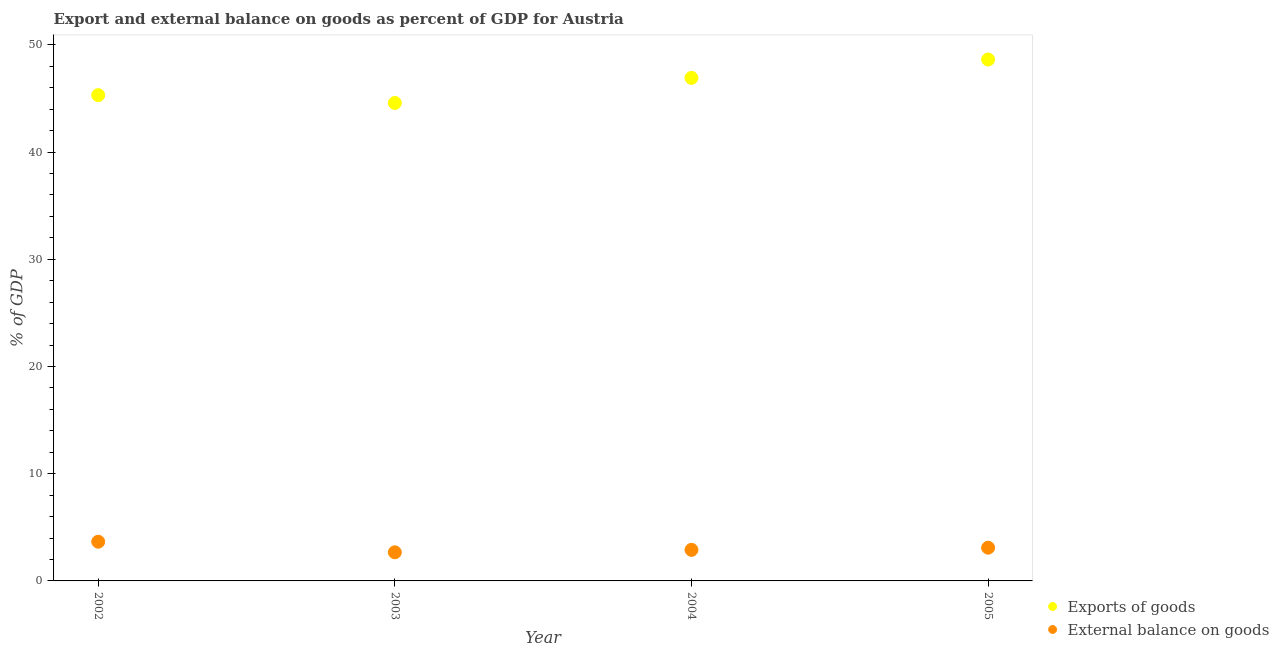Is the number of dotlines equal to the number of legend labels?
Your answer should be compact. Yes. What is the external balance on goods as percentage of gdp in 2005?
Keep it short and to the point. 3.1. Across all years, what is the maximum external balance on goods as percentage of gdp?
Make the answer very short. 3.66. Across all years, what is the minimum export of goods as percentage of gdp?
Offer a very short reply. 44.58. In which year was the export of goods as percentage of gdp minimum?
Your answer should be very brief. 2003. What is the total external balance on goods as percentage of gdp in the graph?
Make the answer very short. 12.32. What is the difference between the export of goods as percentage of gdp in 2003 and that in 2005?
Provide a short and direct response. -4.05. What is the difference between the external balance on goods as percentage of gdp in 2003 and the export of goods as percentage of gdp in 2002?
Offer a terse response. -42.64. What is the average export of goods as percentage of gdp per year?
Keep it short and to the point. 46.36. In the year 2002, what is the difference between the external balance on goods as percentage of gdp and export of goods as percentage of gdp?
Your response must be concise. -41.65. What is the ratio of the export of goods as percentage of gdp in 2003 to that in 2004?
Provide a succinct answer. 0.95. What is the difference between the highest and the second highest export of goods as percentage of gdp?
Make the answer very short. 1.71. What is the difference between the highest and the lowest external balance on goods as percentage of gdp?
Keep it short and to the point. 0.99. Is the sum of the external balance on goods as percentage of gdp in 2003 and 2005 greater than the maximum export of goods as percentage of gdp across all years?
Make the answer very short. No. Is the external balance on goods as percentage of gdp strictly less than the export of goods as percentage of gdp over the years?
Make the answer very short. Yes. How many dotlines are there?
Your response must be concise. 2. How many years are there in the graph?
Offer a terse response. 4. What is the difference between two consecutive major ticks on the Y-axis?
Your response must be concise. 10. How are the legend labels stacked?
Make the answer very short. Vertical. What is the title of the graph?
Your answer should be compact. Export and external balance on goods as percent of GDP for Austria. Does "Chemicals" appear as one of the legend labels in the graph?
Offer a terse response. No. What is the label or title of the Y-axis?
Provide a succinct answer. % of GDP. What is the % of GDP in Exports of goods in 2002?
Your answer should be compact. 45.31. What is the % of GDP in External balance on goods in 2002?
Ensure brevity in your answer.  3.66. What is the % of GDP in Exports of goods in 2003?
Your response must be concise. 44.58. What is the % of GDP of External balance on goods in 2003?
Provide a short and direct response. 2.67. What is the % of GDP of Exports of goods in 2004?
Ensure brevity in your answer.  46.92. What is the % of GDP of External balance on goods in 2004?
Give a very brief answer. 2.9. What is the % of GDP in Exports of goods in 2005?
Keep it short and to the point. 48.63. What is the % of GDP of External balance on goods in 2005?
Provide a short and direct response. 3.1. Across all years, what is the maximum % of GDP of Exports of goods?
Offer a very short reply. 48.63. Across all years, what is the maximum % of GDP of External balance on goods?
Offer a very short reply. 3.66. Across all years, what is the minimum % of GDP of Exports of goods?
Make the answer very short. 44.58. Across all years, what is the minimum % of GDP in External balance on goods?
Offer a very short reply. 2.67. What is the total % of GDP in Exports of goods in the graph?
Make the answer very short. 185.44. What is the total % of GDP in External balance on goods in the graph?
Give a very brief answer. 12.32. What is the difference between the % of GDP in Exports of goods in 2002 and that in 2003?
Offer a very short reply. 0.73. What is the difference between the % of GDP of External balance on goods in 2002 and that in 2003?
Offer a terse response. 0.99. What is the difference between the % of GDP in Exports of goods in 2002 and that in 2004?
Your answer should be compact. -1.61. What is the difference between the % of GDP in External balance on goods in 2002 and that in 2004?
Make the answer very short. 0.76. What is the difference between the % of GDP of Exports of goods in 2002 and that in 2005?
Provide a short and direct response. -3.32. What is the difference between the % of GDP of External balance on goods in 2002 and that in 2005?
Offer a very short reply. 0.56. What is the difference between the % of GDP of Exports of goods in 2003 and that in 2004?
Your answer should be very brief. -2.34. What is the difference between the % of GDP in External balance on goods in 2003 and that in 2004?
Your answer should be very brief. -0.23. What is the difference between the % of GDP in Exports of goods in 2003 and that in 2005?
Offer a terse response. -4.05. What is the difference between the % of GDP of External balance on goods in 2003 and that in 2005?
Provide a short and direct response. -0.43. What is the difference between the % of GDP in Exports of goods in 2004 and that in 2005?
Offer a very short reply. -1.71. What is the difference between the % of GDP in External balance on goods in 2004 and that in 2005?
Ensure brevity in your answer.  -0.2. What is the difference between the % of GDP of Exports of goods in 2002 and the % of GDP of External balance on goods in 2003?
Give a very brief answer. 42.64. What is the difference between the % of GDP of Exports of goods in 2002 and the % of GDP of External balance on goods in 2004?
Offer a very short reply. 42.41. What is the difference between the % of GDP of Exports of goods in 2002 and the % of GDP of External balance on goods in 2005?
Your answer should be compact. 42.21. What is the difference between the % of GDP in Exports of goods in 2003 and the % of GDP in External balance on goods in 2004?
Offer a terse response. 41.68. What is the difference between the % of GDP of Exports of goods in 2003 and the % of GDP of External balance on goods in 2005?
Provide a succinct answer. 41.48. What is the difference between the % of GDP in Exports of goods in 2004 and the % of GDP in External balance on goods in 2005?
Ensure brevity in your answer.  43.82. What is the average % of GDP in Exports of goods per year?
Offer a very short reply. 46.36. What is the average % of GDP of External balance on goods per year?
Provide a short and direct response. 3.08. In the year 2002, what is the difference between the % of GDP in Exports of goods and % of GDP in External balance on goods?
Make the answer very short. 41.65. In the year 2003, what is the difference between the % of GDP in Exports of goods and % of GDP in External balance on goods?
Offer a terse response. 41.91. In the year 2004, what is the difference between the % of GDP of Exports of goods and % of GDP of External balance on goods?
Provide a short and direct response. 44.02. In the year 2005, what is the difference between the % of GDP in Exports of goods and % of GDP in External balance on goods?
Your answer should be compact. 45.53. What is the ratio of the % of GDP in Exports of goods in 2002 to that in 2003?
Make the answer very short. 1.02. What is the ratio of the % of GDP of External balance on goods in 2002 to that in 2003?
Give a very brief answer. 1.37. What is the ratio of the % of GDP in Exports of goods in 2002 to that in 2004?
Make the answer very short. 0.97. What is the ratio of the % of GDP in External balance on goods in 2002 to that in 2004?
Provide a short and direct response. 1.26. What is the ratio of the % of GDP of Exports of goods in 2002 to that in 2005?
Make the answer very short. 0.93. What is the ratio of the % of GDP in External balance on goods in 2002 to that in 2005?
Your response must be concise. 1.18. What is the ratio of the % of GDP in Exports of goods in 2003 to that in 2004?
Offer a terse response. 0.95. What is the ratio of the % of GDP in External balance on goods in 2003 to that in 2004?
Your answer should be very brief. 0.92. What is the ratio of the % of GDP in External balance on goods in 2003 to that in 2005?
Ensure brevity in your answer.  0.86. What is the ratio of the % of GDP of Exports of goods in 2004 to that in 2005?
Ensure brevity in your answer.  0.96. What is the ratio of the % of GDP of External balance on goods in 2004 to that in 2005?
Offer a very short reply. 0.94. What is the difference between the highest and the second highest % of GDP in Exports of goods?
Your response must be concise. 1.71. What is the difference between the highest and the second highest % of GDP in External balance on goods?
Offer a very short reply. 0.56. What is the difference between the highest and the lowest % of GDP of Exports of goods?
Your answer should be compact. 4.05. What is the difference between the highest and the lowest % of GDP in External balance on goods?
Give a very brief answer. 0.99. 